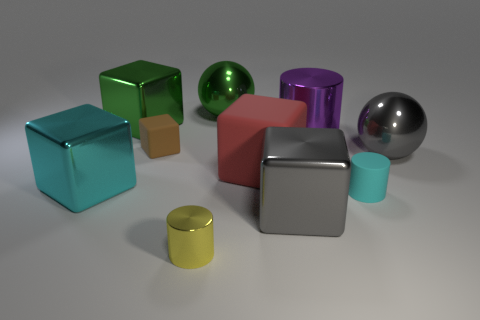Subtract 2 cubes. How many cubes are left? 3 Subtract all small brown blocks. How many blocks are left? 4 Subtract all red cubes. How many cubes are left? 4 Subtract all gray cubes. Subtract all red cylinders. How many cubes are left? 4 Subtract all balls. How many objects are left? 8 Add 3 gray spheres. How many gray spheres exist? 4 Subtract 1 gray balls. How many objects are left? 9 Subtract all tiny cyan matte cylinders. Subtract all big gray metallic spheres. How many objects are left? 8 Add 8 green spheres. How many green spheres are left? 9 